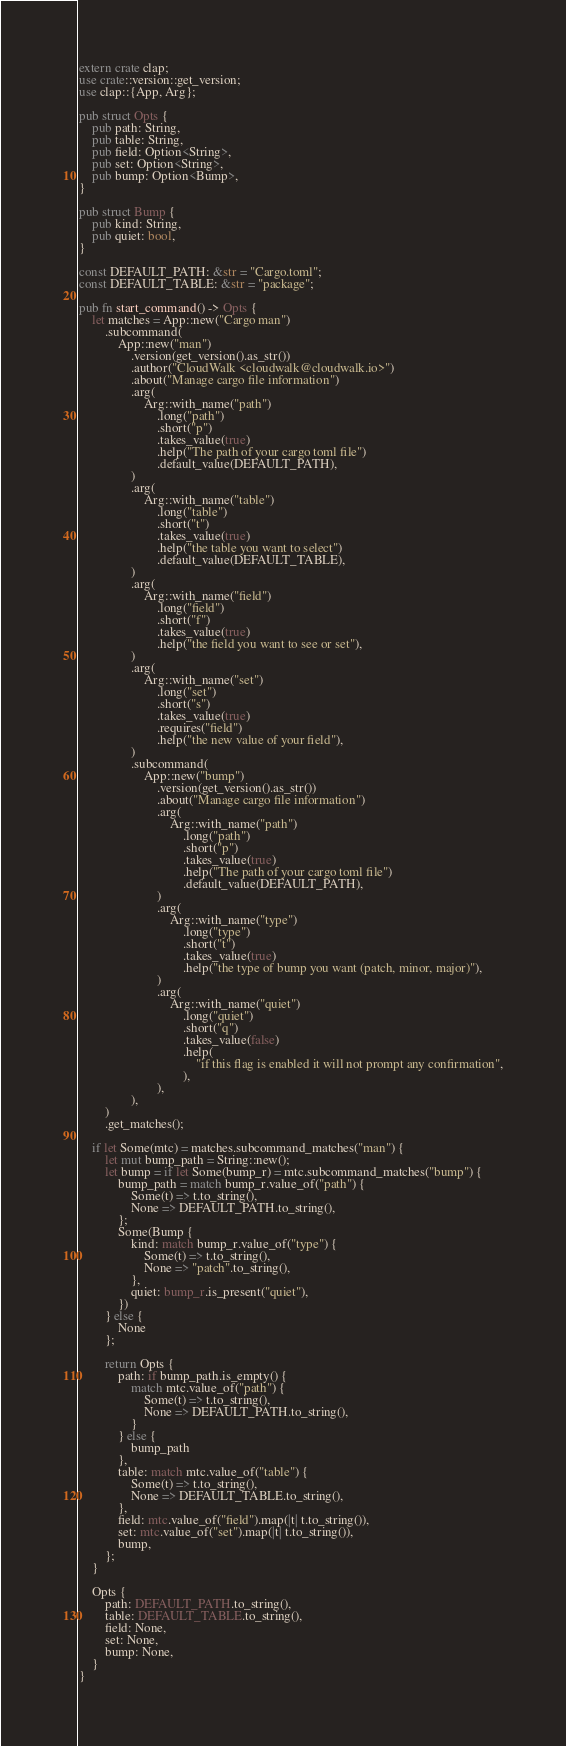Convert code to text. <code><loc_0><loc_0><loc_500><loc_500><_Rust_>extern crate clap;
use crate::version::get_version;
use clap::{App, Arg};

pub struct Opts {
    pub path: String,
    pub table: String,
    pub field: Option<String>,
    pub set: Option<String>,
    pub bump: Option<Bump>,
}

pub struct Bump {
    pub kind: String,
    pub quiet: bool,
}

const DEFAULT_PATH: &str = "Cargo.toml";
const DEFAULT_TABLE: &str = "package";

pub fn start_command() -> Opts {
    let matches = App::new("Cargo man")
        .subcommand(
            App::new("man")
                .version(get_version().as_str())
                .author("CloudWalk <cloudwalk@cloudwalk.io>")
                .about("Manage cargo file information")
                .arg(
                    Arg::with_name("path")
                        .long("path")
                        .short("p")
                        .takes_value(true)
                        .help("The path of your cargo toml file")
                        .default_value(DEFAULT_PATH),
                )
                .arg(
                    Arg::with_name("table")
                        .long("table")
                        .short("t")
                        .takes_value(true)
                        .help("the table you want to select")
                        .default_value(DEFAULT_TABLE),
                )
                .arg(
                    Arg::with_name("field")
                        .long("field")
                        .short("f")
                        .takes_value(true)
                        .help("the field you want to see or set"),
                )
                .arg(
                    Arg::with_name("set")
                        .long("set")
                        .short("s")
                        .takes_value(true)
                        .requires("field")
                        .help("the new value of your field"),
                )
                .subcommand(
                    App::new("bump")
                        .version(get_version().as_str())
                        .about("Manage cargo file information")
                        .arg(
                            Arg::with_name("path")
                                .long("path")
                                .short("p")
                                .takes_value(true)
                                .help("The path of your cargo toml file")
                                .default_value(DEFAULT_PATH),
                        )
                        .arg(
                            Arg::with_name("type")
                                .long("type")
                                .short("t")
                                .takes_value(true)
                                .help("the type of bump you want (patch, minor, major)"),
                        )
                        .arg(
                            Arg::with_name("quiet")
                                .long("quiet")
                                .short("q")
                                .takes_value(false)
                                .help(
                                    "if this flag is enabled it will not prompt any confirmation",
                                ),
                        ),
                ),
        )
        .get_matches();

    if let Some(mtc) = matches.subcommand_matches("man") {
        let mut bump_path = String::new();
        let bump = if let Some(bump_r) = mtc.subcommand_matches("bump") {
            bump_path = match bump_r.value_of("path") {
                Some(t) => t.to_string(),
                None => DEFAULT_PATH.to_string(),
            };
            Some(Bump {
                kind: match bump_r.value_of("type") {
                    Some(t) => t.to_string(),
                    None => "patch".to_string(),
                },
                quiet: bump_r.is_present("quiet"),
            })
        } else {
            None
        };

        return Opts {
            path: if bump_path.is_empty() {
                match mtc.value_of("path") {
                    Some(t) => t.to_string(),
                    None => DEFAULT_PATH.to_string(),
                }
            } else {
                bump_path
            },
            table: match mtc.value_of("table") {
                Some(t) => t.to_string(),
                None => DEFAULT_TABLE.to_string(),
            },
            field: mtc.value_of("field").map(|t| t.to_string()),
            set: mtc.value_of("set").map(|t| t.to_string()),
            bump,
        };
    }

    Opts {
        path: DEFAULT_PATH.to_string(),
        table: DEFAULT_TABLE.to_string(),
        field: None,
        set: None,
        bump: None,
    }
}
</code> 